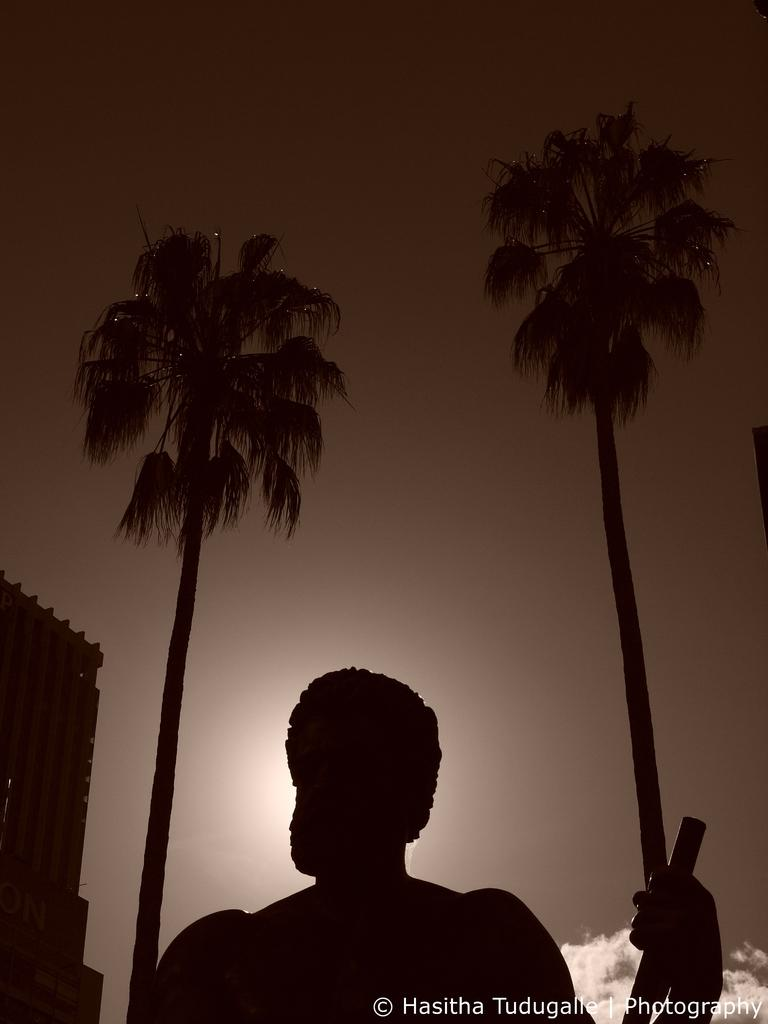What is the person in the image holding? There is a person holding an object in the image. What type of natural environment can be seen in the image? There are trees in the image. What type of structure is visible in the image? There is a building in the image. Where can text be found in the image? Text is written at the right bottom of the image. How many cats are visible in the image? There are no cats present in the image. Is there a gun visible in the image? There is no gun present in the image. 